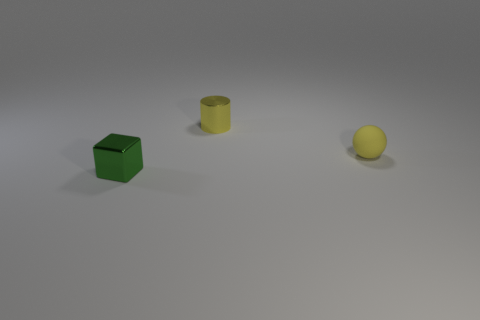Add 3 small spheres. How many objects exist? 6 Subtract all balls. How many objects are left? 2 Add 2 cylinders. How many cylinders exist? 3 Subtract 0 cyan blocks. How many objects are left? 3 Subtract all small metallic cylinders. Subtract all small yellow things. How many objects are left? 0 Add 1 yellow rubber objects. How many yellow rubber objects are left? 2 